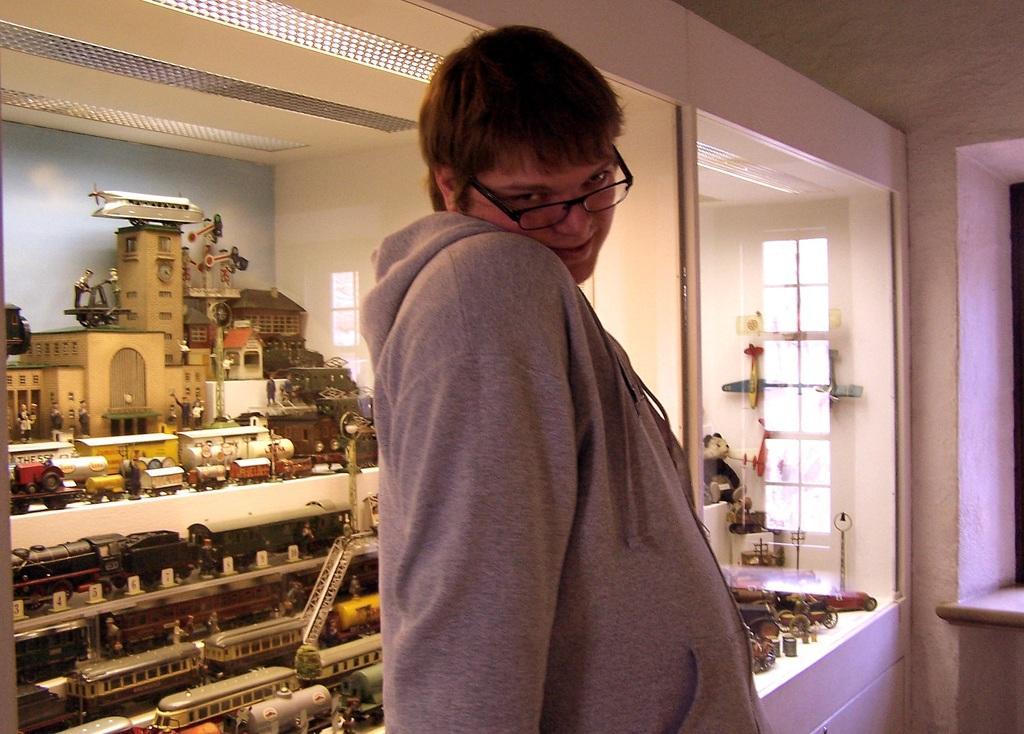Can you describe this image briefly? In this picture we can see a person,he is wearing a spectacles and in the background we can see some toys,wall. 